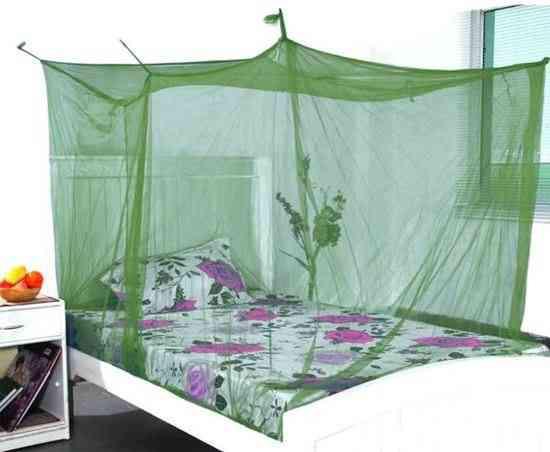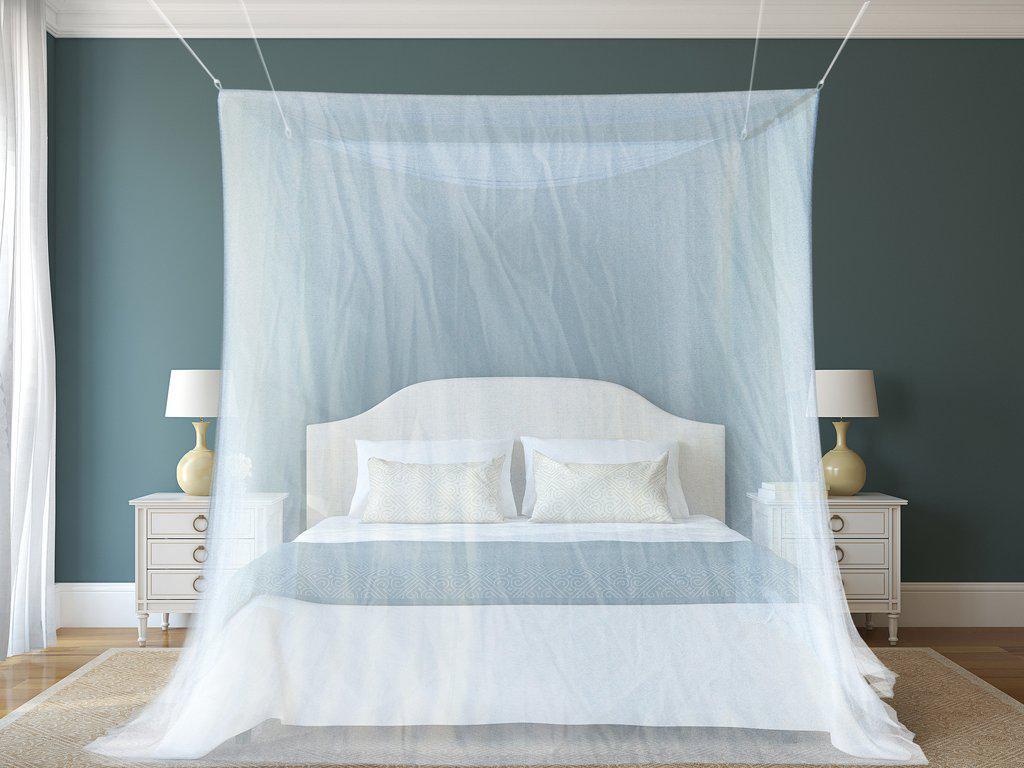The first image is the image on the left, the second image is the image on the right. Examine the images to the left and right. Is the description "One bed net has a fabric bottom trim." accurate? Answer yes or no. No. The first image is the image on the left, the second image is the image on the right. Given the left and right images, does the statement "One image shows a head-on view of a bed surrounded by a square sheer white canopy that covers the foot of the bed and suspends from its top corners." hold true? Answer yes or no. Yes. 